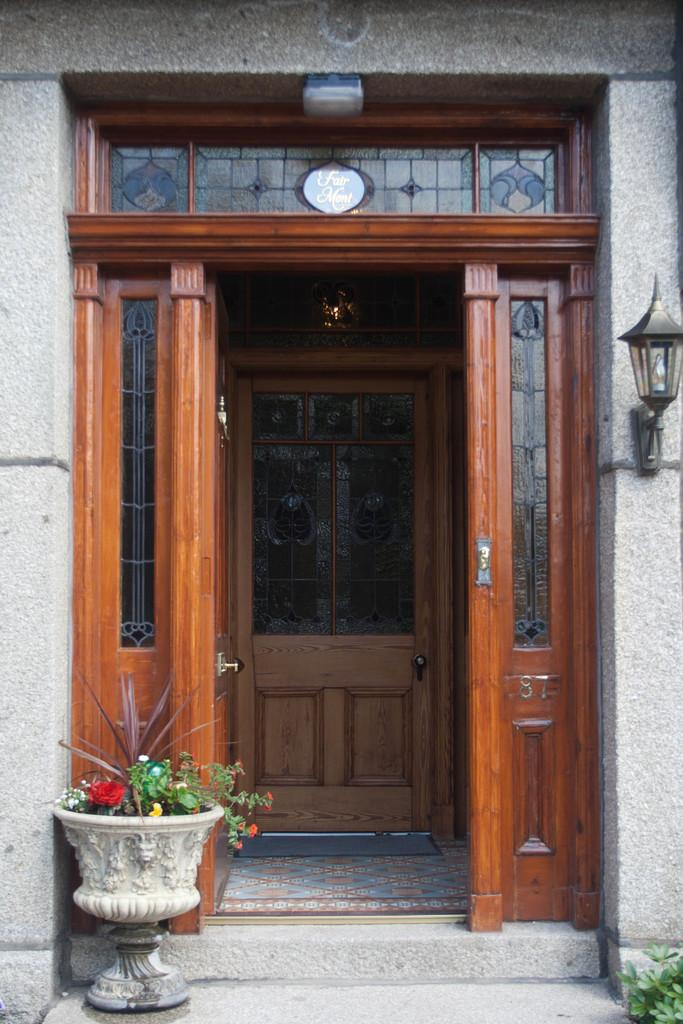What type of vegetation is present in the image? There are flowers and plants in the image. What is the flowers and plants contained in? There is a pot in the image that contains the flowers and plants. What architectural features can be seen in the image? There are doors and a light attached to the wall in the image. What is on the floor in the image? There is a mat on the floor in the image. Can you see a bat flying in the sky in the image? There is no bat or sky present in the image. What shape is the circle that the flowers form in the image? There is no circle formed by the flowers in the image; the flowers are contained within a pot. 